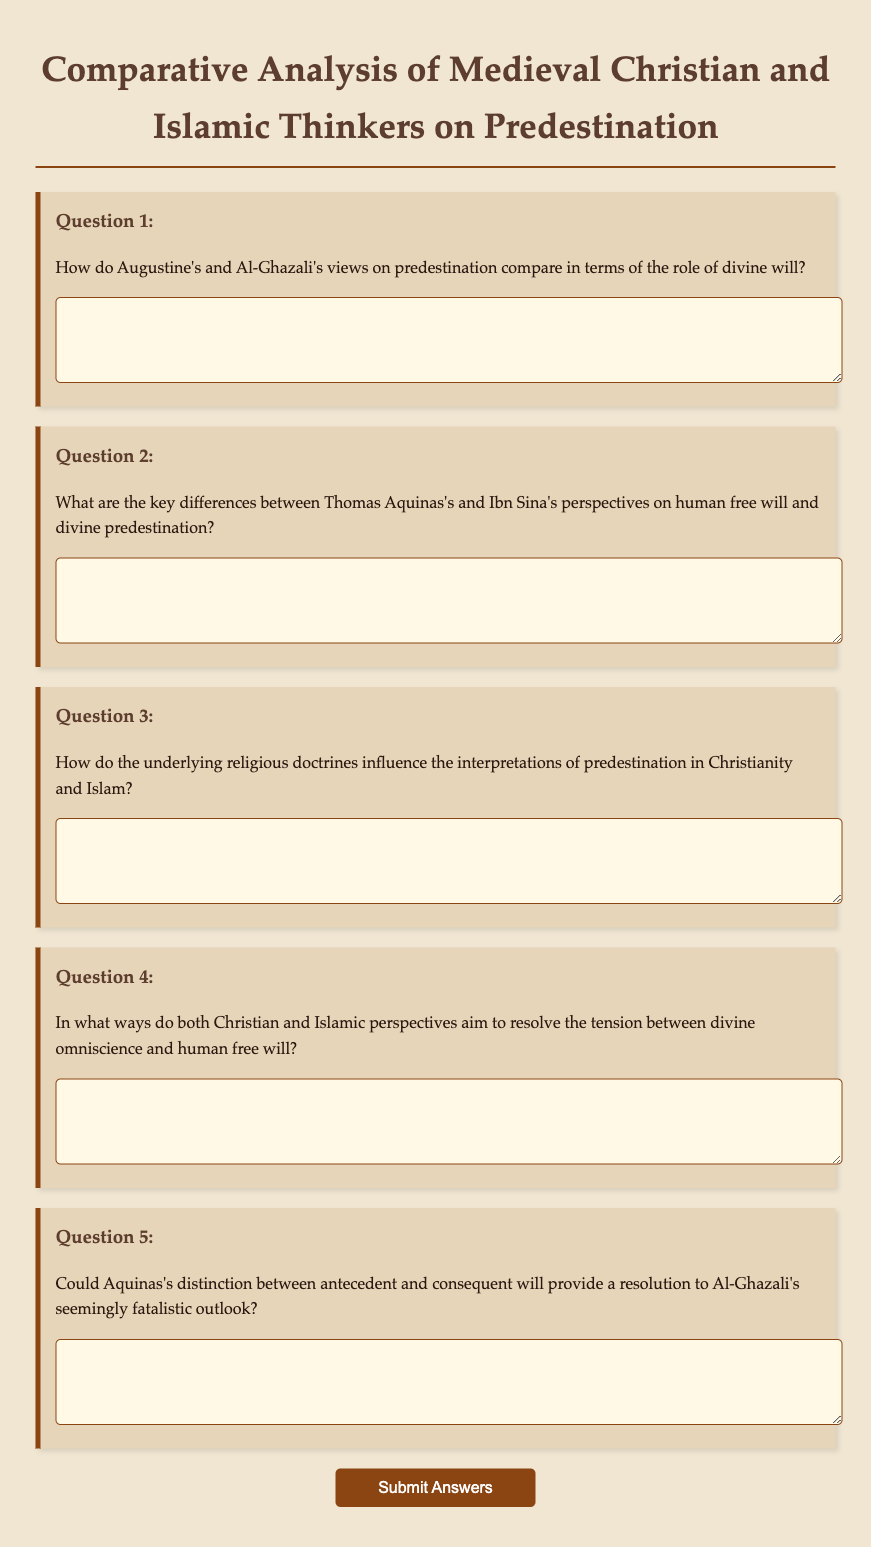What is the title of the document? The title is displayed prominently at the top of the document, reflecting its focus area.
Answer: Comparative Analysis of Medieval Christian and Islamic Thinkers on Predestination How many questions are included in the questionnaire? The document lists a total of five questions within the form.
Answer: 5 Who are the two thinkers compared in Question 1? The names of the thinkers are explicitly mentioned in the text of Question 1.
Answer: Augustine and Al-Ghazali What is the primary topic of inquiry in the questionnaire? The questionnaire revolves around interpretations regarding a specific theological concept.
Answer: Predestination Which two figures are discussed in Question 2 regarding free will? The document specifies the names of the figures to compare perspectives on this topic.
Answer: Thomas Aquinas and Ibn Sina What kind of perspectives does Question 4 ask to explore? The question prompts an exploration of how two religious perspectives address an inherent philosophical issue.
Answer: Divine omniscience and human free will What is the purpose of the submit button in the questionnaire? The button is designed to allow participants to finalize and send their responses once they've completed the form.
Answer: Submit Answers 